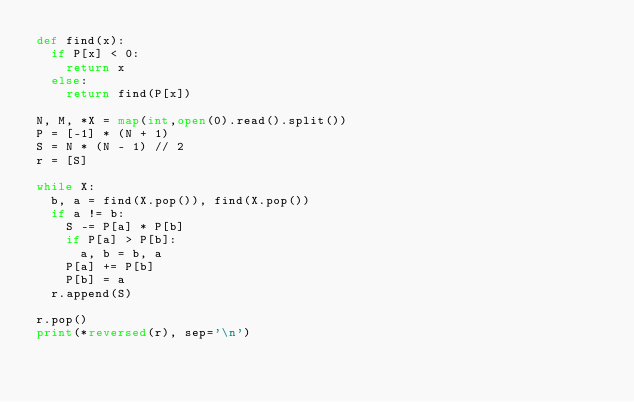<code> <loc_0><loc_0><loc_500><loc_500><_Python_>def find(x):
  if P[x] < 0:
    return x
  else:
    return find(P[x])

N, M, *X = map(int,open(0).read().split())
P = [-1] * (N + 1)
S = N * (N - 1) // 2
r = [S]

while X:
  b, a = find(X.pop()), find(X.pop())
  if a != b:
    S -= P[a] * P[b]
    if P[a] > P[b]:
      a, b = b, a
    P[a] += P[b]
    P[b] = a
  r.append(S)

r.pop()
print(*reversed(r), sep='\n')</code> 